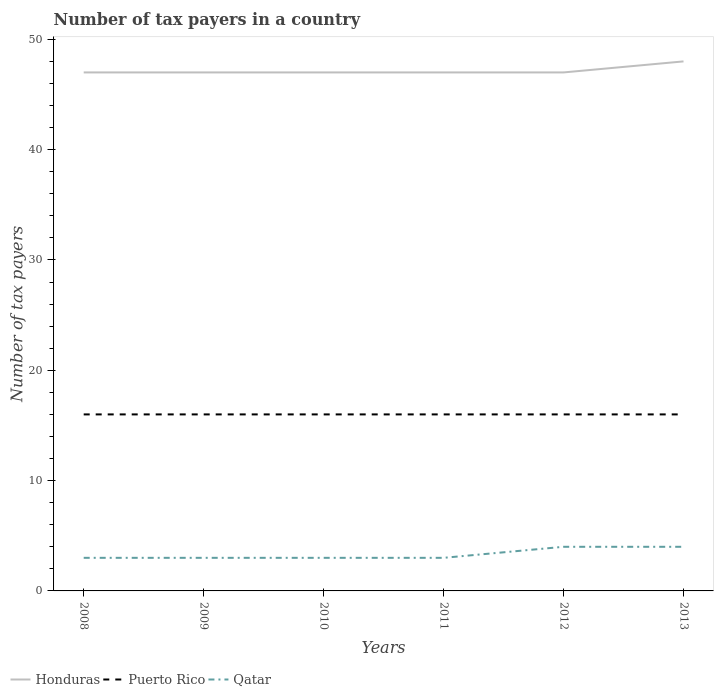How many different coloured lines are there?
Your answer should be compact. 3. Is the number of lines equal to the number of legend labels?
Keep it short and to the point. Yes. Across all years, what is the maximum number of tax payers in in Honduras?
Your response must be concise. 47. In which year was the number of tax payers in in Honduras maximum?
Provide a short and direct response. 2008. What is the total number of tax payers in in Puerto Rico in the graph?
Provide a short and direct response. 0. What is the difference between the highest and the lowest number of tax payers in in Qatar?
Give a very brief answer. 2. Is the number of tax payers in in Puerto Rico strictly greater than the number of tax payers in in Honduras over the years?
Your answer should be compact. Yes. What is the difference between two consecutive major ticks on the Y-axis?
Provide a short and direct response. 10. Does the graph contain grids?
Your answer should be compact. No. Where does the legend appear in the graph?
Your answer should be very brief. Bottom left. How many legend labels are there?
Keep it short and to the point. 3. How are the legend labels stacked?
Your response must be concise. Horizontal. What is the title of the graph?
Your answer should be compact. Number of tax payers in a country. Does "Bulgaria" appear as one of the legend labels in the graph?
Your answer should be compact. No. What is the label or title of the X-axis?
Offer a very short reply. Years. What is the label or title of the Y-axis?
Provide a succinct answer. Number of tax payers. What is the Number of tax payers in Puerto Rico in 2009?
Your answer should be compact. 16. What is the Number of tax payers of Puerto Rico in 2011?
Give a very brief answer. 16. What is the Number of tax payers in Honduras in 2012?
Offer a terse response. 47. What is the Number of tax payers in Puerto Rico in 2012?
Offer a very short reply. 16. What is the Number of tax payers of Honduras in 2013?
Your answer should be compact. 48. Across all years, what is the maximum Number of tax payers in Qatar?
Provide a succinct answer. 4. Across all years, what is the minimum Number of tax payers of Qatar?
Your answer should be very brief. 3. What is the total Number of tax payers in Honduras in the graph?
Your response must be concise. 283. What is the total Number of tax payers of Puerto Rico in the graph?
Your answer should be very brief. 96. What is the difference between the Number of tax payers in Honduras in 2008 and that in 2009?
Keep it short and to the point. 0. What is the difference between the Number of tax payers in Puerto Rico in 2008 and that in 2009?
Ensure brevity in your answer.  0. What is the difference between the Number of tax payers of Qatar in 2008 and that in 2009?
Your answer should be compact. 0. What is the difference between the Number of tax payers of Honduras in 2008 and that in 2010?
Provide a short and direct response. 0. What is the difference between the Number of tax payers in Puerto Rico in 2008 and that in 2010?
Your answer should be very brief. 0. What is the difference between the Number of tax payers of Qatar in 2008 and that in 2010?
Provide a succinct answer. 0. What is the difference between the Number of tax payers of Puerto Rico in 2008 and that in 2011?
Provide a short and direct response. 0. What is the difference between the Number of tax payers of Qatar in 2008 and that in 2011?
Make the answer very short. 0. What is the difference between the Number of tax payers in Honduras in 2008 and that in 2012?
Provide a succinct answer. 0. What is the difference between the Number of tax payers of Puerto Rico in 2008 and that in 2012?
Your answer should be compact. 0. What is the difference between the Number of tax payers of Qatar in 2008 and that in 2013?
Give a very brief answer. -1. What is the difference between the Number of tax payers of Honduras in 2009 and that in 2010?
Give a very brief answer. 0. What is the difference between the Number of tax payers in Puerto Rico in 2009 and that in 2010?
Offer a terse response. 0. What is the difference between the Number of tax payers of Puerto Rico in 2009 and that in 2011?
Keep it short and to the point. 0. What is the difference between the Number of tax payers in Qatar in 2009 and that in 2011?
Your answer should be very brief. 0. What is the difference between the Number of tax payers of Honduras in 2009 and that in 2012?
Make the answer very short. 0. What is the difference between the Number of tax payers of Puerto Rico in 2009 and that in 2012?
Your answer should be compact. 0. What is the difference between the Number of tax payers of Qatar in 2009 and that in 2012?
Make the answer very short. -1. What is the difference between the Number of tax payers of Puerto Rico in 2009 and that in 2013?
Give a very brief answer. 0. What is the difference between the Number of tax payers of Puerto Rico in 2010 and that in 2011?
Provide a short and direct response. 0. What is the difference between the Number of tax payers of Qatar in 2010 and that in 2011?
Keep it short and to the point. 0. What is the difference between the Number of tax payers of Puerto Rico in 2010 and that in 2012?
Give a very brief answer. 0. What is the difference between the Number of tax payers of Qatar in 2010 and that in 2012?
Make the answer very short. -1. What is the difference between the Number of tax payers in Honduras in 2011 and that in 2012?
Offer a very short reply. 0. What is the difference between the Number of tax payers of Honduras in 2011 and that in 2013?
Ensure brevity in your answer.  -1. What is the difference between the Number of tax payers of Puerto Rico in 2011 and that in 2013?
Ensure brevity in your answer.  0. What is the difference between the Number of tax payers in Honduras in 2012 and that in 2013?
Keep it short and to the point. -1. What is the difference between the Number of tax payers in Qatar in 2012 and that in 2013?
Offer a terse response. 0. What is the difference between the Number of tax payers of Honduras in 2008 and the Number of tax payers of Puerto Rico in 2009?
Keep it short and to the point. 31. What is the difference between the Number of tax payers of Honduras in 2008 and the Number of tax payers of Qatar in 2009?
Your response must be concise. 44. What is the difference between the Number of tax payers in Puerto Rico in 2008 and the Number of tax payers in Qatar in 2009?
Your response must be concise. 13. What is the difference between the Number of tax payers in Puerto Rico in 2008 and the Number of tax payers in Qatar in 2010?
Provide a succinct answer. 13. What is the difference between the Number of tax payers of Honduras in 2008 and the Number of tax payers of Puerto Rico in 2012?
Keep it short and to the point. 31. What is the difference between the Number of tax payers of Honduras in 2008 and the Number of tax payers of Qatar in 2013?
Keep it short and to the point. 43. What is the difference between the Number of tax payers in Puerto Rico in 2008 and the Number of tax payers in Qatar in 2013?
Give a very brief answer. 12. What is the difference between the Number of tax payers of Honduras in 2009 and the Number of tax payers of Puerto Rico in 2010?
Offer a very short reply. 31. What is the difference between the Number of tax payers of Honduras in 2009 and the Number of tax payers of Puerto Rico in 2011?
Provide a succinct answer. 31. What is the difference between the Number of tax payers of Honduras in 2009 and the Number of tax payers of Qatar in 2011?
Make the answer very short. 44. What is the difference between the Number of tax payers of Puerto Rico in 2009 and the Number of tax payers of Qatar in 2011?
Make the answer very short. 13. What is the difference between the Number of tax payers in Honduras in 2009 and the Number of tax payers in Puerto Rico in 2012?
Offer a terse response. 31. What is the difference between the Number of tax payers in Honduras in 2009 and the Number of tax payers in Qatar in 2012?
Your response must be concise. 43. What is the difference between the Number of tax payers of Puerto Rico in 2009 and the Number of tax payers of Qatar in 2012?
Provide a succinct answer. 12. What is the difference between the Number of tax payers of Honduras in 2009 and the Number of tax payers of Puerto Rico in 2013?
Keep it short and to the point. 31. What is the difference between the Number of tax payers in Honduras in 2009 and the Number of tax payers in Qatar in 2013?
Offer a very short reply. 43. What is the difference between the Number of tax payers in Honduras in 2010 and the Number of tax payers in Qatar in 2011?
Your answer should be very brief. 44. What is the difference between the Number of tax payers in Honduras in 2010 and the Number of tax payers in Puerto Rico in 2012?
Offer a very short reply. 31. What is the difference between the Number of tax payers in Puerto Rico in 2010 and the Number of tax payers in Qatar in 2012?
Give a very brief answer. 12. What is the difference between the Number of tax payers of Honduras in 2010 and the Number of tax payers of Qatar in 2013?
Offer a terse response. 43. What is the difference between the Number of tax payers in Honduras in 2011 and the Number of tax payers in Puerto Rico in 2012?
Offer a very short reply. 31. What is the difference between the Number of tax payers in Puerto Rico in 2011 and the Number of tax payers in Qatar in 2012?
Your response must be concise. 12. What is the difference between the Number of tax payers in Honduras in 2011 and the Number of tax payers in Puerto Rico in 2013?
Offer a very short reply. 31. What is the difference between the Number of tax payers in Honduras in 2011 and the Number of tax payers in Qatar in 2013?
Make the answer very short. 43. What is the difference between the Number of tax payers in Honduras in 2012 and the Number of tax payers in Qatar in 2013?
Your response must be concise. 43. What is the average Number of tax payers in Honduras per year?
Give a very brief answer. 47.17. What is the average Number of tax payers of Puerto Rico per year?
Your answer should be compact. 16. In the year 2008, what is the difference between the Number of tax payers of Honduras and Number of tax payers of Puerto Rico?
Provide a succinct answer. 31. In the year 2008, what is the difference between the Number of tax payers in Puerto Rico and Number of tax payers in Qatar?
Your answer should be very brief. 13. In the year 2010, what is the difference between the Number of tax payers in Honduras and Number of tax payers in Puerto Rico?
Provide a succinct answer. 31. In the year 2010, what is the difference between the Number of tax payers of Honduras and Number of tax payers of Qatar?
Ensure brevity in your answer.  44. In the year 2011, what is the difference between the Number of tax payers of Honduras and Number of tax payers of Puerto Rico?
Offer a terse response. 31. In the year 2011, what is the difference between the Number of tax payers of Honduras and Number of tax payers of Qatar?
Your answer should be very brief. 44. In the year 2011, what is the difference between the Number of tax payers in Puerto Rico and Number of tax payers in Qatar?
Offer a very short reply. 13. In the year 2012, what is the difference between the Number of tax payers of Puerto Rico and Number of tax payers of Qatar?
Ensure brevity in your answer.  12. In the year 2013, what is the difference between the Number of tax payers in Puerto Rico and Number of tax payers in Qatar?
Offer a very short reply. 12. What is the ratio of the Number of tax payers in Puerto Rico in 2008 to that in 2009?
Make the answer very short. 1. What is the ratio of the Number of tax payers of Qatar in 2008 to that in 2009?
Offer a very short reply. 1. What is the ratio of the Number of tax payers of Qatar in 2008 to that in 2010?
Ensure brevity in your answer.  1. What is the ratio of the Number of tax payers in Honduras in 2008 to that in 2011?
Keep it short and to the point. 1. What is the ratio of the Number of tax payers in Honduras in 2008 to that in 2012?
Offer a very short reply. 1. What is the ratio of the Number of tax payers of Honduras in 2008 to that in 2013?
Keep it short and to the point. 0.98. What is the ratio of the Number of tax payers in Puerto Rico in 2008 to that in 2013?
Your response must be concise. 1. What is the ratio of the Number of tax payers in Qatar in 2008 to that in 2013?
Offer a very short reply. 0.75. What is the ratio of the Number of tax payers of Honduras in 2009 to that in 2010?
Keep it short and to the point. 1. What is the ratio of the Number of tax payers of Puerto Rico in 2009 to that in 2010?
Make the answer very short. 1. What is the ratio of the Number of tax payers in Honduras in 2009 to that in 2011?
Your answer should be compact. 1. What is the ratio of the Number of tax payers in Qatar in 2009 to that in 2012?
Offer a very short reply. 0.75. What is the ratio of the Number of tax payers of Honduras in 2009 to that in 2013?
Offer a terse response. 0.98. What is the ratio of the Number of tax payers of Puerto Rico in 2009 to that in 2013?
Offer a very short reply. 1. What is the ratio of the Number of tax payers in Qatar in 2009 to that in 2013?
Offer a terse response. 0.75. What is the ratio of the Number of tax payers in Honduras in 2010 to that in 2011?
Your response must be concise. 1. What is the ratio of the Number of tax payers in Honduras in 2010 to that in 2012?
Keep it short and to the point. 1. What is the ratio of the Number of tax payers of Puerto Rico in 2010 to that in 2012?
Provide a succinct answer. 1. What is the ratio of the Number of tax payers of Honduras in 2010 to that in 2013?
Ensure brevity in your answer.  0.98. What is the ratio of the Number of tax payers in Puerto Rico in 2010 to that in 2013?
Ensure brevity in your answer.  1. What is the ratio of the Number of tax payers in Qatar in 2010 to that in 2013?
Offer a very short reply. 0.75. What is the ratio of the Number of tax payers of Honduras in 2011 to that in 2012?
Your answer should be very brief. 1. What is the ratio of the Number of tax payers of Puerto Rico in 2011 to that in 2012?
Give a very brief answer. 1. What is the ratio of the Number of tax payers in Honduras in 2011 to that in 2013?
Give a very brief answer. 0.98. What is the ratio of the Number of tax payers of Puerto Rico in 2011 to that in 2013?
Provide a succinct answer. 1. What is the ratio of the Number of tax payers in Qatar in 2011 to that in 2013?
Your answer should be very brief. 0.75. What is the ratio of the Number of tax payers in Honduras in 2012 to that in 2013?
Your answer should be very brief. 0.98. What is the ratio of the Number of tax payers in Puerto Rico in 2012 to that in 2013?
Provide a short and direct response. 1. 